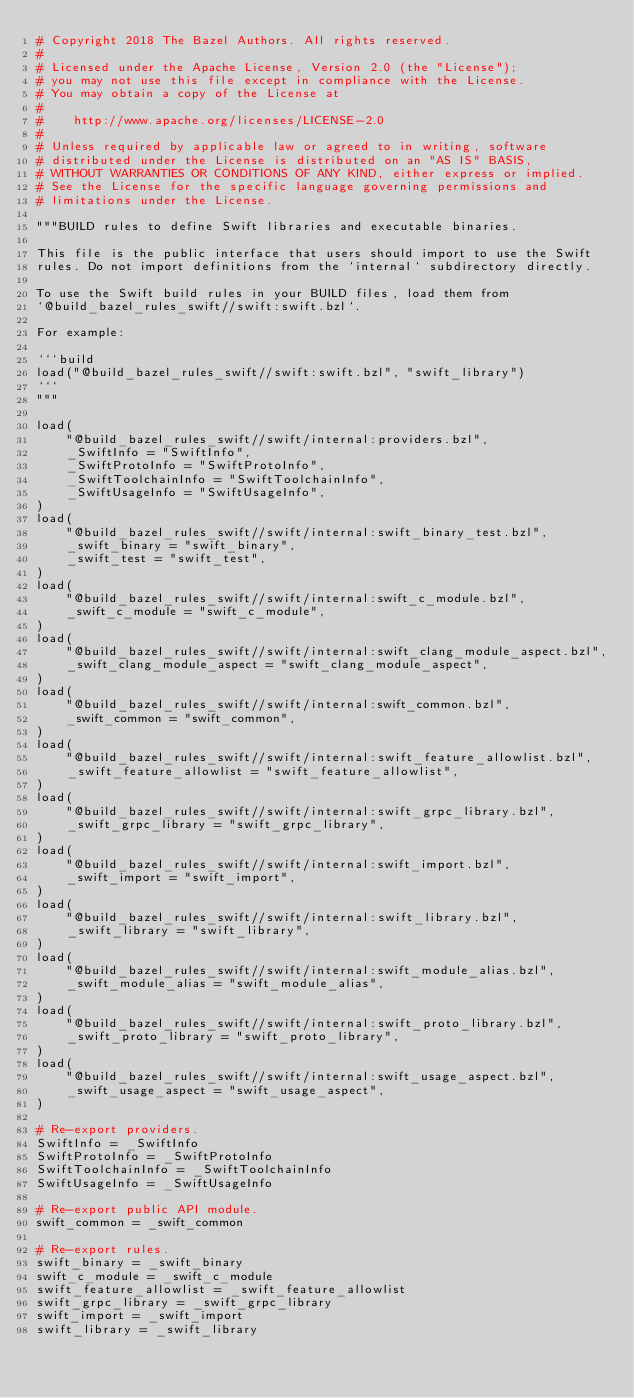<code> <loc_0><loc_0><loc_500><loc_500><_Python_># Copyright 2018 The Bazel Authors. All rights reserved.
#
# Licensed under the Apache License, Version 2.0 (the "License");
# you may not use this file except in compliance with the License.
# You may obtain a copy of the License at
#
#    http://www.apache.org/licenses/LICENSE-2.0
#
# Unless required by applicable law or agreed to in writing, software
# distributed under the License is distributed on an "AS IS" BASIS,
# WITHOUT WARRANTIES OR CONDITIONS OF ANY KIND, either express or implied.
# See the License for the specific language governing permissions and
# limitations under the License.

"""BUILD rules to define Swift libraries and executable binaries.

This file is the public interface that users should import to use the Swift
rules. Do not import definitions from the `internal` subdirectory directly.

To use the Swift build rules in your BUILD files, load them from
`@build_bazel_rules_swift//swift:swift.bzl`.

For example:

```build
load("@build_bazel_rules_swift//swift:swift.bzl", "swift_library")
```
"""

load(
    "@build_bazel_rules_swift//swift/internal:providers.bzl",
    _SwiftInfo = "SwiftInfo",
    _SwiftProtoInfo = "SwiftProtoInfo",
    _SwiftToolchainInfo = "SwiftToolchainInfo",
    _SwiftUsageInfo = "SwiftUsageInfo",
)
load(
    "@build_bazel_rules_swift//swift/internal:swift_binary_test.bzl",
    _swift_binary = "swift_binary",
    _swift_test = "swift_test",
)
load(
    "@build_bazel_rules_swift//swift/internal:swift_c_module.bzl",
    _swift_c_module = "swift_c_module",
)
load(
    "@build_bazel_rules_swift//swift/internal:swift_clang_module_aspect.bzl",
    _swift_clang_module_aspect = "swift_clang_module_aspect",
)
load(
    "@build_bazel_rules_swift//swift/internal:swift_common.bzl",
    _swift_common = "swift_common",
)
load(
    "@build_bazel_rules_swift//swift/internal:swift_feature_allowlist.bzl",
    _swift_feature_allowlist = "swift_feature_allowlist",
)
load(
    "@build_bazel_rules_swift//swift/internal:swift_grpc_library.bzl",
    _swift_grpc_library = "swift_grpc_library",
)
load(
    "@build_bazel_rules_swift//swift/internal:swift_import.bzl",
    _swift_import = "swift_import",
)
load(
    "@build_bazel_rules_swift//swift/internal:swift_library.bzl",
    _swift_library = "swift_library",
)
load(
    "@build_bazel_rules_swift//swift/internal:swift_module_alias.bzl",
    _swift_module_alias = "swift_module_alias",
)
load(
    "@build_bazel_rules_swift//swift/internal:swift_proto_library.bzl",
    _swift_proto_library = "swift_proto_library",
)
load(
    "@build_bazel_rules_swift//swift/internal:swift_usage_aspect.bzl",
    _swift_usage_aspect = "swift_usage_aspect",
)

# Re-export providers.
SwiftInfo = _SwiftInfo
SwiftProtoInfo = _SwiftProtoInfo
SwiftToolchainInfo = _SwiftToolchainInfo
SwiftUsageInfo = _SwiftUsageInfo

# Re-export public API module.
swift_common = _swift_common

# Re-export rules.
swift_binary = _swift_binary
swift_c_module = _swift_c_module
swift_feature_allowlist = _swift_feature_allowlist
swift_grpc_library = _swift_grpc_library
swift_import = _swift_import
swift_library = _swift_library</code> 